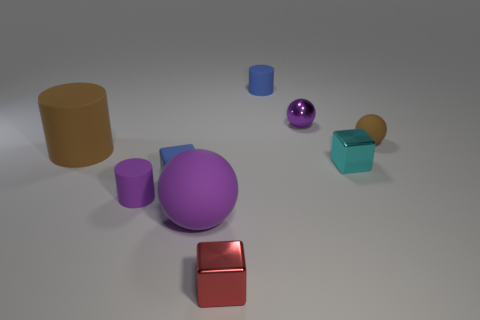Subtract all big brown cylinders. How many cylinders are left? 2 Subtract all red blocks. How many blocks are left? 2 Subtract 1 cubes. How many cubes are left? 2 Subtract all balls. How many objects are left? 6 Subtract all cyan cubes. Subtract all gray spheres. How many cubes are left? 2 Add 2 purple metallic things. How many purple metallic things exist? 3 Subtract 0 gray cylinders. How many objects are left? 9 Subtract all blue cubes. How many cyan spheres are left? 0 Subtract all rubber spheres. Subtract all purple cylinders. How many objects are left? 6 Add 5 big matte cylinders. How many big matte cylinders are left? 6 